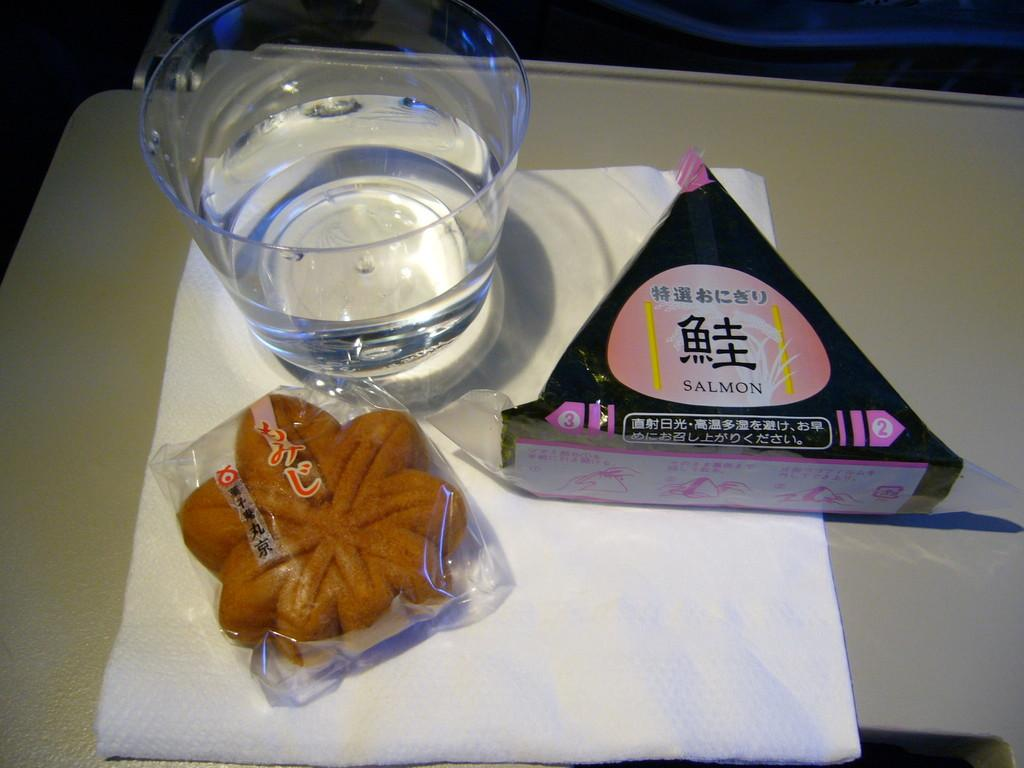What is the tissue paper placed on in the image? The tissue paper is placed on a white surface. What can be seen on the tissue paper? There are objects on the tissue paper. How does the tissue paper kick the objects on it in the image? The tissue paper does not kick the objects; it is an inanimate object and cannot perform actions like kicking. 